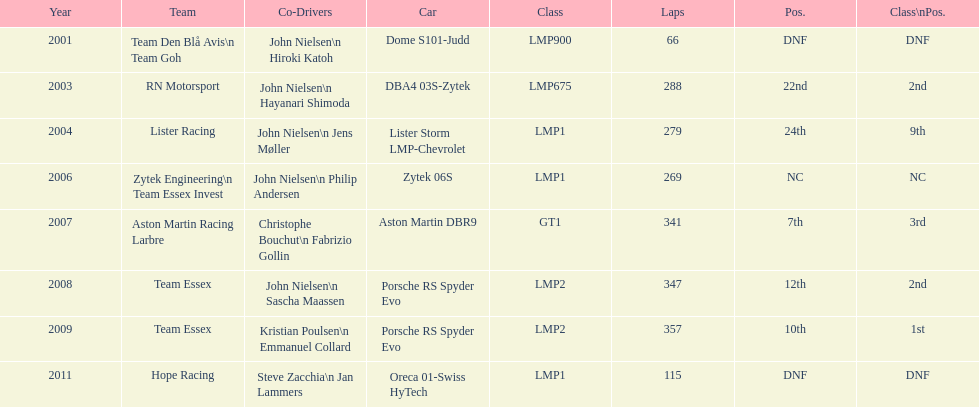What is the total number of races that have been participated in? 8. 